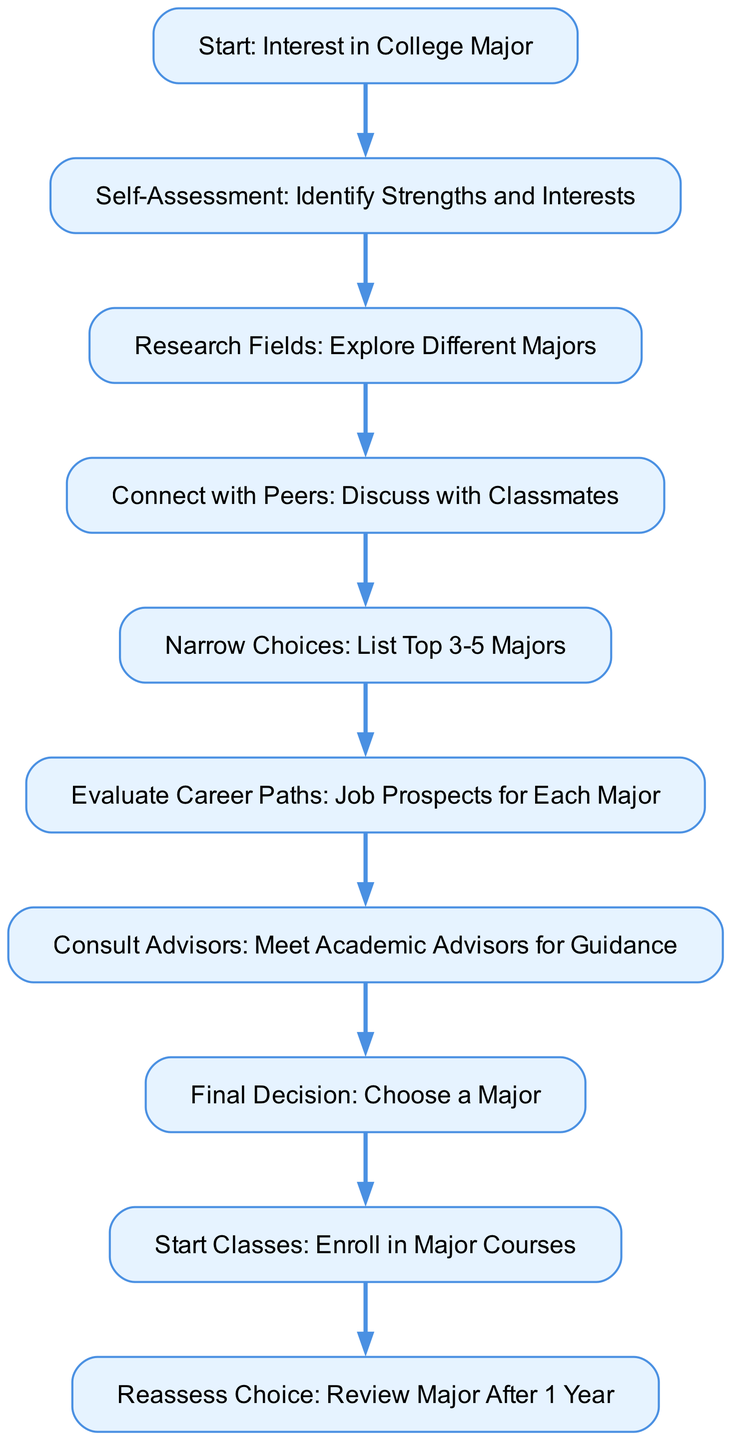What is the first step in the flow chart? The flow chart starts with the node labeled "Start: Interest in College Major," which is the initial step that guides the process.
Answer: Start: Interest in College Major How many nodes are present in the diagram? By counting all the unique steps or boxes in the flow chart, we can see there are ten distinct nodes from "Start" to "Reassess Choice."
Answer: 10 Which node comes directly after "Narrow Choices"? In the flow chart, "Evaluate Career Paths" follows "Narrow Choices," indicating the next step after narrowing down major options.
Answer: Evaluate Career Paths What is the last step before starting classes? The concluding step before enrolling is labeled "Final Decision," serving as the crucial point where students choose their major.
Answer: Final Decision What is the relationship between "Connect with Peers" and "Narrow Choices"? The diagram shows a direct connection from "Connect with Peers" leading to "Narrow Choices," indicating that discussing with classmates helps to refine major options.
Answer: Leading to What are the top three steps in order? The first three steps in the flow chart are "Start: Interest in College Major," "Self-Assessment: Identify Strengths and Interests," and "Research Fields: Explore Different Majors," which outline the initial processes before making a decision.
Answer: Start: Interest in College Major, Self-Assessment: Identify Strengths and Interests, Research Fields: Explore Different Majors How do you move from "Consult Advisors" to "Final Decision"? The diagram shows a direct path from "Consult Advisors" to "Final Decision," which means that after meeting with academic advisors, the student is ready to choose their major.
Answer: Direct path Which step involves interaction with academic advisors? The step labeled "Consult Advisors: Meet Academic Advisors for Guidance" specifically involves interacting with academic advisors for further advice.
Answer: Consult Advisors: Meet Academic Advisors for Guidance What step comes after reassessing the major? After "Reassess Choice: Review Major After 1 Year," there are no further steps indicated, meaning this is the final step in this flowchart.
Answer: No further steps 